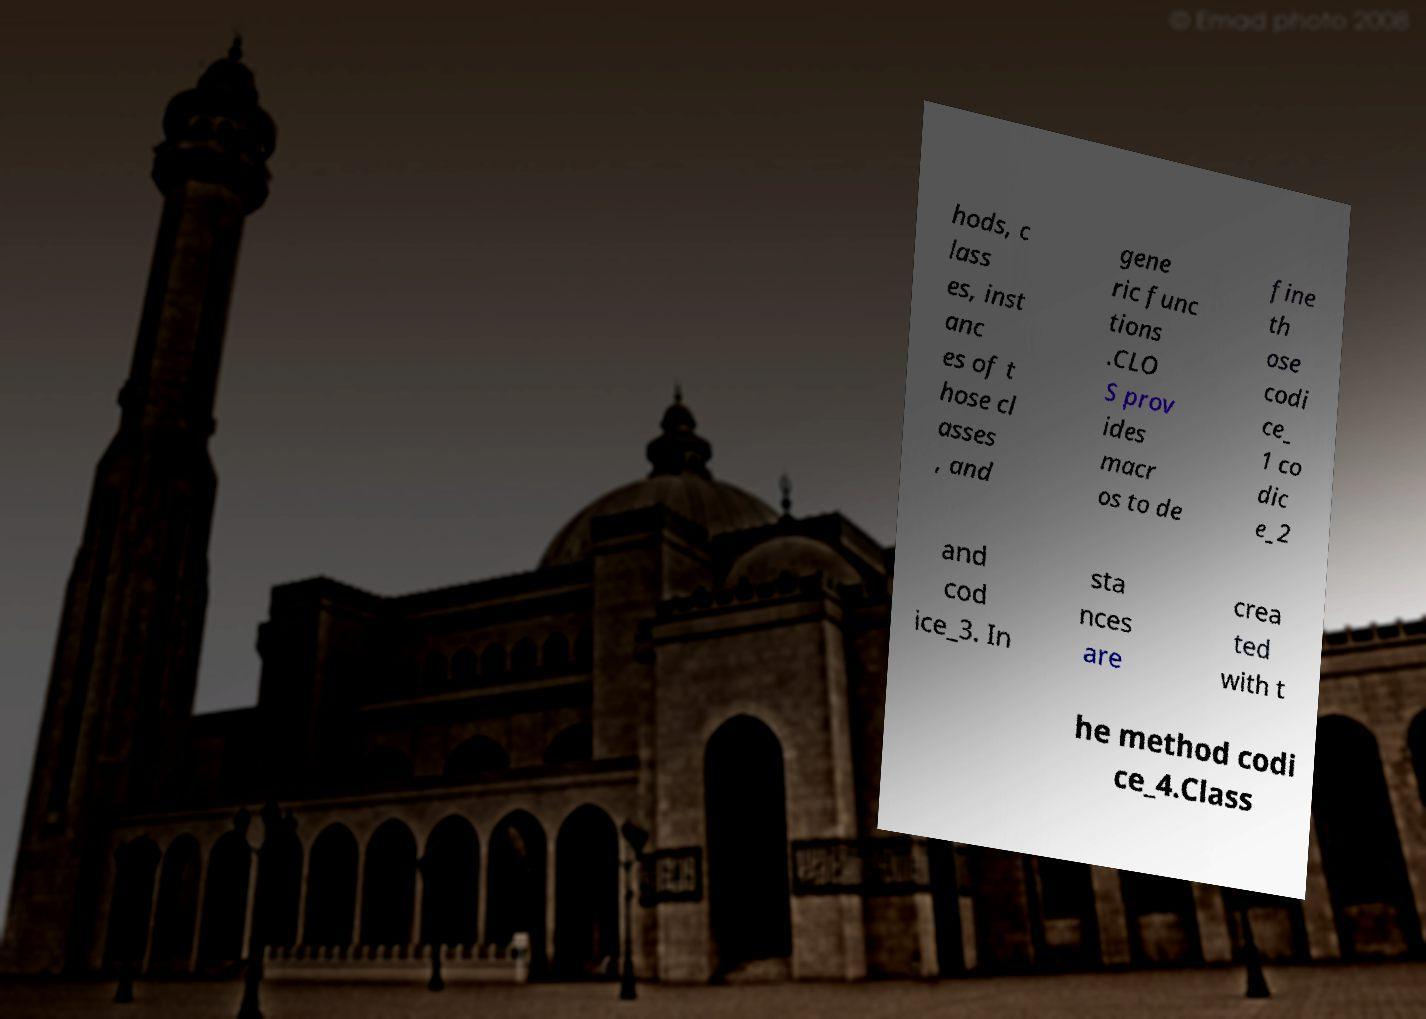Could you assist in decoding the text presented in this image and type it out clearly? hods, c lass es, inst anc es of t hose cl asses , and gene ric func tions .CLO S prov ides macr os to de fine th ose codi ce_ 1 co dic e_2 and cod ice_3. In sta nces are crea ted with t he method codi ce_4.Class 